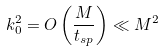Convert formula to latex. <formula><loc_0><loc_0><loc_500><loc_500>k _ { 0 } ^ { 2 } = O \left ( \frac { M } { t _ { s p } } \right ) \ll M ^ { 2 }</formula> 